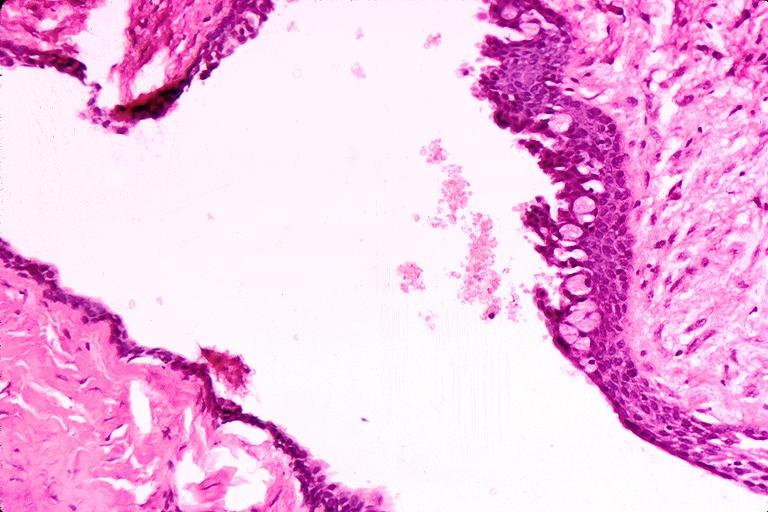does pituitary show cyst?
Answer the question using a single word or phrase. No 